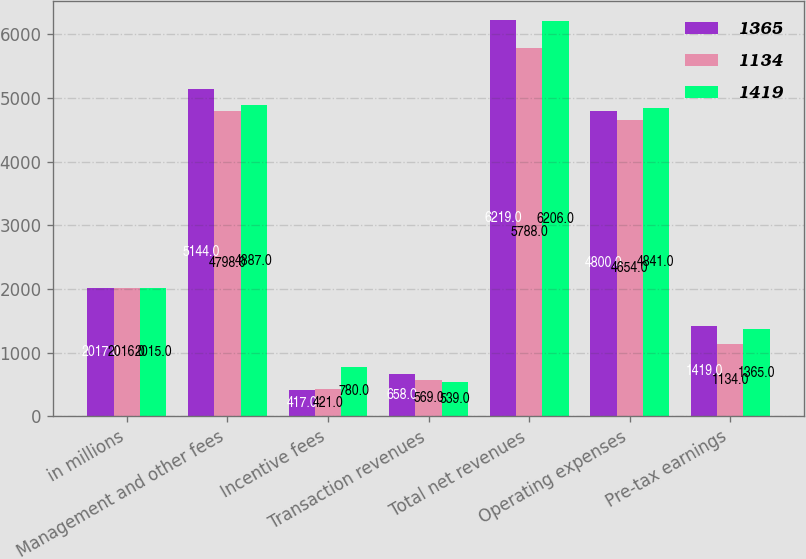<chart> <loc_0><loc_0><loc_500><loc_500><stacked_bar_chart><ecel><fcel>in millions<fcel>Management and other fees<fcel>Incentive fees<fcel>Transaction revenues<fcel>Total net revenues<fcel>Operating expenses<fcel>Pre-tax earnings<nl><fcel>1365<fcel>2017<fcel>5144<fcel>417<fcel>658<fcel>6219<fcel>4800<fcel>1419<nl><fcel>1134<fcel>2016<fcel>4798<fcel>421<fcel>569<fcel>5788<fcel>4654<fcel>1134<nl><fcel>1419<fcel>2015<fcel>4887<fcel>780<fcel>539<fcel>6206<fcel>4841<fcel>1365<nl></chart> 